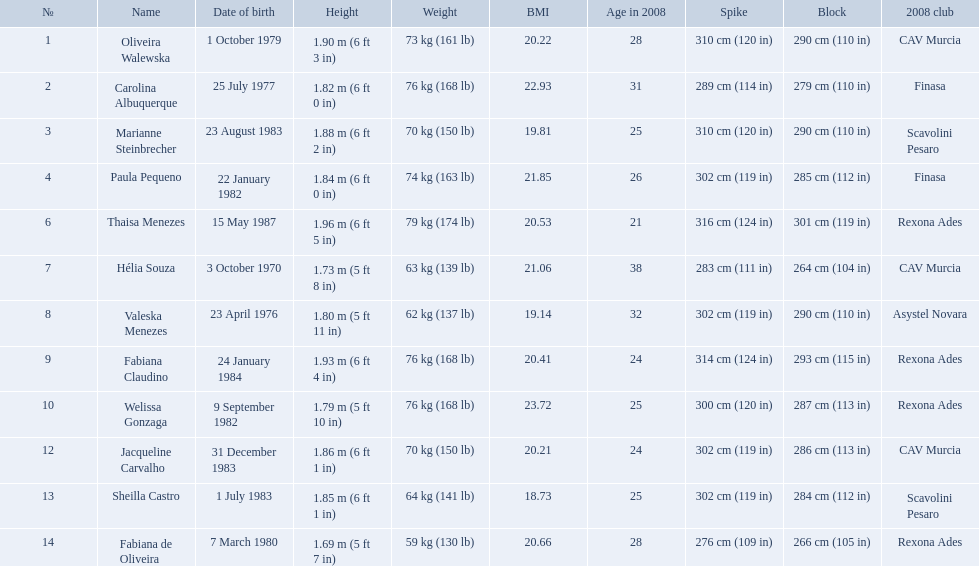How much does fabiana de oliveira weigh? 76 kg (168 lb). How much does helia souza weigh? 63 kg (139 lb). How much does sheilla castro weigh? 64 kg (141 lb). Whose weight did the original question asker incorrectly believe to be the heaviest (they are the second heaviest)? Sheilla Castro. Who played during the brazil at the 2008 summer olympics event? Oliveira Walewska, Carolina Albuquerque, Marianne Steinbrecher, Paula Pequeno, Thaisa Menezes, Hélia Souza, Valeska Menezes, Fabiana Claudino, Welissa Gonzaga, Jacqueline Carvalho, Sheilla Castro, Fabiana de Oliveira. And what was the recorded height of each player? 1.90 m (6 ft 3 in), 1.82 m (6 ft 0 in), 1.88 m (6 ft 2 in), 1.84 m (6 ft 0 in), 1.96 m (6 ft 5 in), 1.73 m (5 ft 8 in), 1.80 m (5 ft 11 in), 1.93 m (6 ft 4 in), 1.79 m (5 ft 10 in), 1.86 m (6 ft 1 in), 1.85 m (6 ft 1 in), 1.69 m (5 ft 7 in). Of those, which player is the shortest? Fabiana de Oliveira. What are the heights of the players? 1.90 m (6 ft 3 in), 1.82 m (6 ft 0 in), 1.88 m (6 ft 2 in), 1.84 m (6 ft 0 in), 1.96 m (6 ft 5 in), 1.73 m (5 ft 8 in), 1.80 m (5 ft 11 in), 1.93 m (6 ft 4 in), 1.79 m (5 ft 10 in), 1.86 m (6 ft 1 in), 1.85 m (6 ft 1 in), 1.69 m (5 ft 7 in). Which of these heights is the shortest? 1.69 m (5 ft 7 in). Which player is 5'7 tall? Fabiana de Oliveira. Who are the players for brazil at the 2008 summer olympics? Oliveira Walewska, Carolina Albuquerque, Marianne Steinbrecher, Paula Pequeno, Thaisa Menezes, Hélia Souza, Valeska Menezes, Fabiana Claudino, Welissa Gonzaga, Jacqueline Carvalho, Sheilla Castro, Fabiana de Oliveira. What are their heights? 1.90 m (6 ft 3 in), 1.82 m (6 ft 0 in), 1.88 m (6 ft 2 in), 1.84 m (6 ft 0 in), 1.96 m (6 ft 5 in), 1.73 m (5 ft 8 in), 1.80 m (5 ft 11 in), 1.93 m (6 ft 4 in), 1.79 m (5 ft 10 in), 1.86 m (6 ft 1 in), 1.85 m (6 ft 1 in), 1.69 m (5 ft 7 in). What is the shortest height? 1.69 m (5 ft 7 in). Parse the full table. {'header': ['№', 'Name', 'Date of birth', 'Height', 'Weight', 'BMI', 'Age in 2008', 'Spike', 'Block', '2008 club'], 'rows': [['1', 'Oliveira Walewska', '1 October 1979', '1.90\xa0m (6\xa0ft 3\xa0in)', '73\xa0kg (161\xa0lb)', '20.22', '28', '310\xa0cm (120\xa0in)', '290\xa0cm (110\xa0in)', 'CAV Murcia'], ['2', 'Carolina Albuquerque', '25 July 1977', '1.82\xa0m (6\xa0ft 0\xa0in)', '76\xa0kg (168\xa0lb)', '22.93', '31', '289\xa0cm (114\xa0in)', '279\xa0cm (110\xa0in)', 'Finasa'], ['3', 'Marianne Steinbrecher', '23 August 1983', '1.88\xa0m (6\xa0ft 2\xa0in)', '70\xa0kg (150\xa0lb)', '19.81', '25', '310\xa0cm (120\xa0in)', '290\xa0cm (110\xa0in)', 'Scavolini Pesaro'], ['4', 'Paula Pequeno', '22 January 1982', '1.84\xa0m (6\xa0ft 0\xa0in)', '74\xa0kg (163\xa0lb)', '21.85', '26', '302\xa0cm (119\xa0in)', '285\xa0cm (112\xa0in)', 'Finasa'], ['6', 'Thaisa Menezes', '15 May 1987', '1.96\xa0m (6\xa0ft 5\xa0in)', '79\xa0kg (174\xa0lb)', '20.53', '21', '316\xa0cm (124\xa0in)', '301\xa0cm (119\xa0in)', 'Rexona Ades'], ['7', 'Hélia Souza', '3 October 1970', '1.73\xa0m (5\xa0ft 8\xa0in)', '63\xa0kg (139\xa0lb)', '21.06', '38', '283\xa0cm (111\xa0in)', '264\xa0cm (104\xa0in)', 'CAV Murcia'], ['8', 'Valeska Menezes', '23 April 1976', '1.80\xa0m (5\xa0ft 11\xa0in)', '62\xa0kg (137\xa0lb)', '19.14', '32', '302\xa0cm (119\xa0in)', '290\xa0cm (110\xa0in)', 'Asystel Novara'], ['9', 'Fabiana Claudino', '24 January 1984', '1.93\xa0m (6\xa0ft 4\xa0in)', '76\xa0kg (168\xa0lb)', '20.41', '24', '314\xa0cm (124\xa0in)', '293\xa0cm (115\xa0in)', 'Rexona Ades'], ['10', 'Welissa Gonzaga', '9 September 1982', '1.79\xa0m (5\xa0ft 10\xa0in)', '76\xa0kg (168\xa0lb)', '23.72', '25', '300\xa0cm (120\xa0in)', '287\xa0cm (113\xa0in)', 'Rexona Ades'], ['12', 'Jacqueline Carvalho', '31 December 1983', '1.86\xa0m (6\xa0ft 1\xa0in)', '70\xa0kg (150\xa0lb)', '20.21', '24', '302\xa0cm (119\xa0in)', '286\xa0cm (113\xa0in)', 'CAV Murcia'], ['13', 'Sheilla Castro', '1 July 1983', '1.85\xa0m (6\xa0ft 1\xa0in)', '64\xa0kg (141\xa0lb)', '18.73', '25', '302\xa0cm (119\xa0in)', '284\xa0cm (112\xa0in)', 'Scavolini Pesaro'], ['14', 'Fabiana de Oliveira', '7 March 1980', '1.69\xa0m (5\xa0ft 7\xa0in)', '59\xa0kg (130\xa0lb)', '20.66', '28', '276\xa0cm (109\xa0in)', '266\xa0cm (105\xa0in)', 'Rexona Ades']]} Which player is that? Fabiana de Oliveira. 